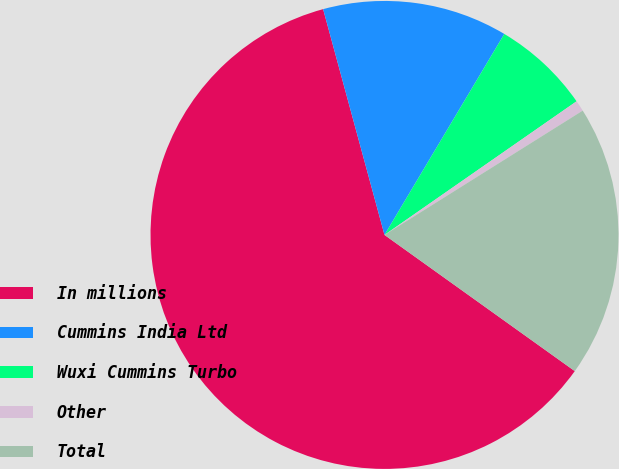Convert chart. <chart><loc_0><loc_0><loc_500><loc_500><pie_chart><fcel>In millions<fcel>Cummins India Ltd<fcel>Wuxi Cummins Turbo<fcel>Other<fcel>Total<nl><fcel>60.89%<fcel>12.78%<fcel>6.77%<fcel>0.76%<fcel>18.8%<nl></chart> 